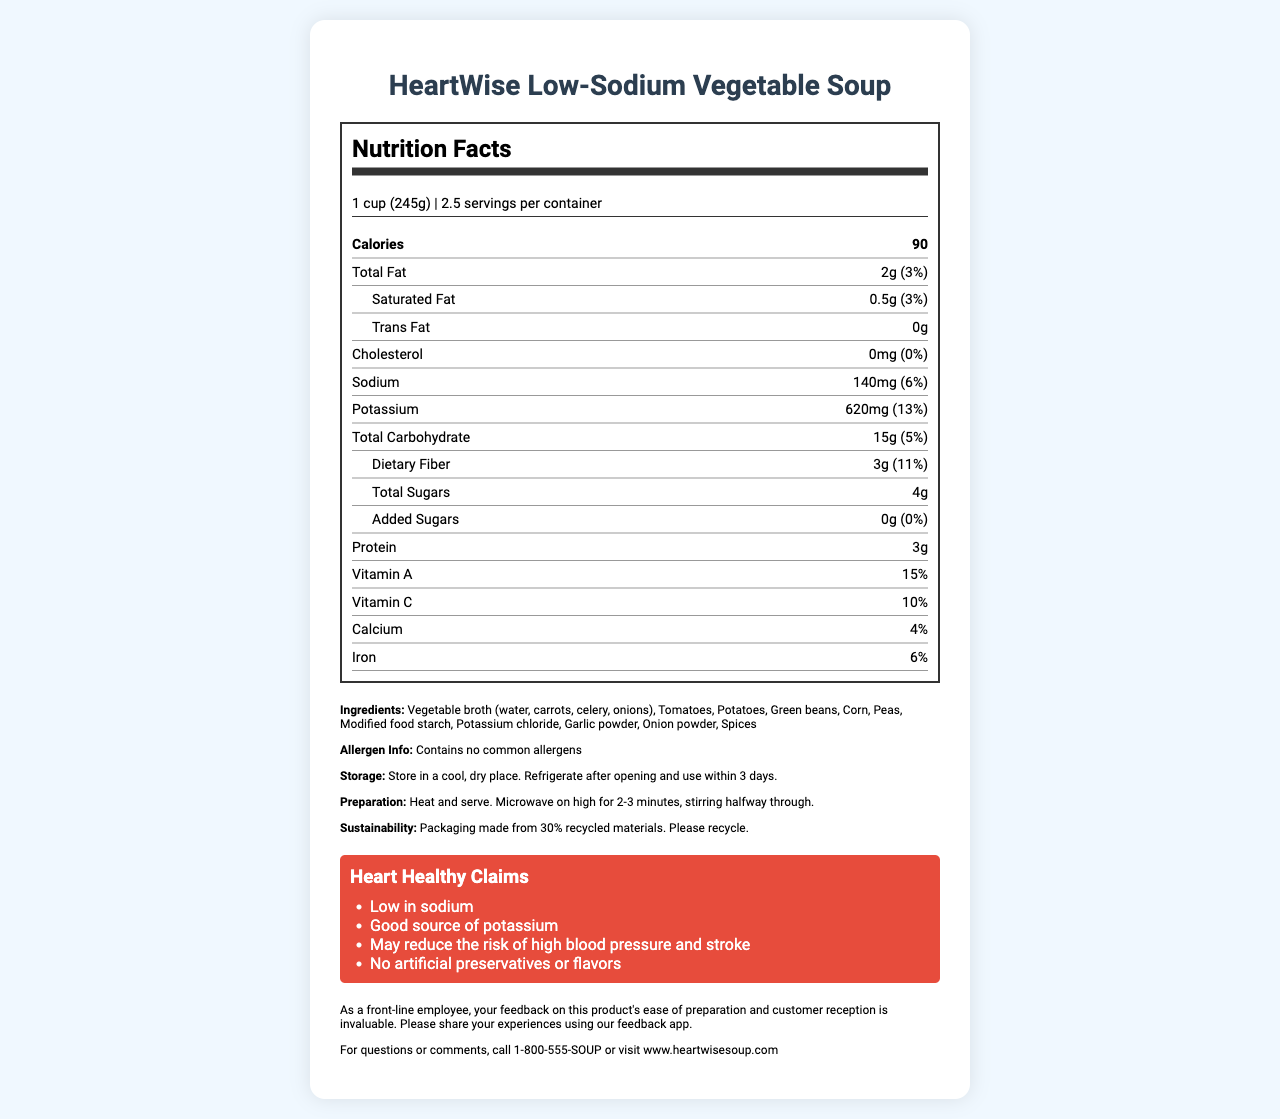What is the serving size of the HeartWise Low-Sodium Vegetable Soup? The serving size is explicitly mentioned in the document as "1 cup (245g)".
Answer: 1 cup (245g) How many calories are there per serving? The document states that there are 90 calories per serving.
Answer: 90 What is the total fat content per serving? The document lists the total fat per serving as 2g.
Answer: 2g What percentage of daily value does the sodium content represent? The sodium content is stated as 140mg, which is 6% of the daily value.
Answer: 6% How much dietary fiber is in one serving? The dietary fiber content per serving is explicitly stated as 3g.
Answer: 3g What is the potassium content per serving? The document specifies that there are 620mg of potassium per serving.
Answer: 620mg Which ingredient is not included in the HeartWise Low-Sodium Vegetable Soup? A. Tomatoes B. Chicken broth C. Potatoes D. Garlic powder The list of ingredients does not include chicken broth, but does include tomatoes, potatoes, and garlic powder.
Answer: B What are the heart-healthy claims of the product? A. Low in sodium B. Good source of potassium C. May reduce the risk of high blood pressure and stroke D. All of the above The document lists all of these items as heart-healthy claims.
Answer: D Does the product contain any common allergens? The allergen information explicitly states that the product contains no common allergens.
Answer: No Can this product help in reducing the risk of high blood pressure? One of the heart-healthy claims states that the product may reduce the risk of high blood pressure and stroke.
Answer: Yes Summarize the key information presented in the document. The document is well-organized and gives comprehensive information about the nutritional content, health benefits, and other relevant details of the HeartWise Low-Sodium Vegetable Soup.
Answer: The document provides detailed nutritional information for the HeartWise Low-Sodium Vegetable Soup, including serving size, calorie count, and percentages of daily values for various nutrients. The product is low in sodium, high in potassium, and contains no common allergens. It also includes information on ingredients, storage, preparation, heart-healthy claims, and sustainability practices. How many grams of added sugars are in one serving? The added sugars per serving are explicitly listed as 0g.
Answer: 0g What is the recommended storage instruction for the product? The recommended storage instructions are stated in the document.
Answer: Store in a cool, dry place. Refrigerate after opening and use within 3 days. What is the preparation instruction for the product? The preparation instructions specify heating and serving, with specific microwave instructions provided.
Answer: Heat and serve. Microwave on high for 2-3 minutes, stirring halfway through. Is the packaging of the product environmentally sustainable? The document states that the packaging is made from 30% recycled materials and encourages recycling.
Answer: Yes How is the daily value percentage for cholesterol listed? The document states the daily value for cholesterol as 0%.
Answer: 0% What are the vitamins present in the product and their daily values? The document lists Vitamin A with 15% and Vitamin C with 10% of the daily value.
Answer: Vitamin A (15%), Vitamin C (10%) Can this soup help in meeting daily protein requirements significantly? The product contains 3g of protein per serving, which is relatively low and may not significantly contribute to meeting daily protein requirements.
Answer: No Is the product free from artificial preservatives or flavors? The document claims that the product has no artificial preservatives or flavors.
Answer: Yes What is the total carbohydrate content per serving and its percentage of the daily value? The total carbohydrate content is listed as 15g, which is 5% of the daily value.
Answer: 15g (5%) What is the percentage of daily value for dietary fiber in one serving? The document lists the daily value for dietary fiber as 11%.
Answer: 11% What are the contact details for customer inquiries? The contact details for questions or comments are listed as a phone number and website.
Answer: 1-800-555-SOUP or visit www.heartwisesoup.com What is the main ingredient in the soup? The first ingredient listed, which is typically the main ingredient, is vegetable broth (water, carrots, celery, onions).
Answer: Vegetable broth (water, carrots, celery, onions) What flavors are added to enhance the taste of the soup? The flavors listed in the ingredients include garlic powder, onion powder, and spices.
Answer: Garlic powder, onion powder, spices Who should provide feedback on the product's ease of preparation and customer reception? The document specifically asks for feedback from a front-line employee using the feedback app.
Answer: Front-line employee 